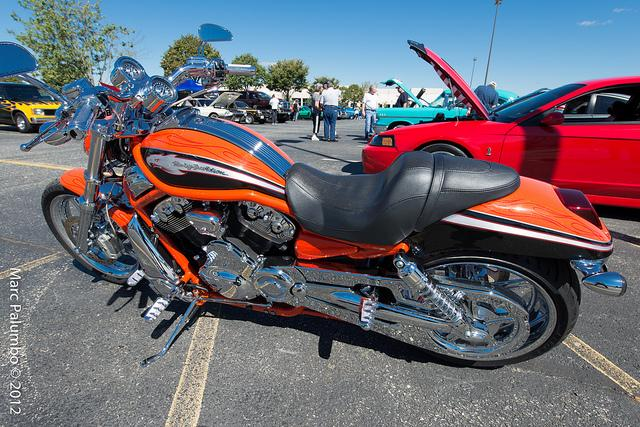What is the silver area of the bike made of? Please explain your reasoning. chrome. The silver part of the bike is chrome. 